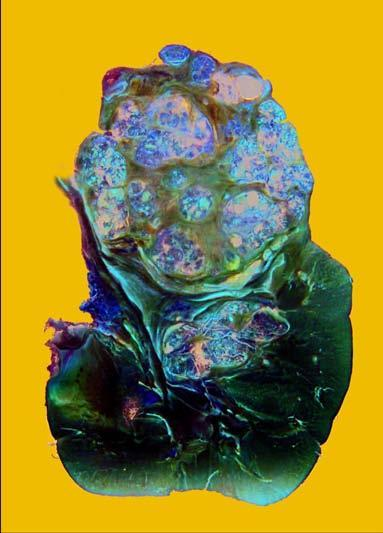what shows irregular, circumscribed, yellowish mass with areas of haemorrhages and necrosis?
Answer the question using a single word or phrase. Sectioned surface 